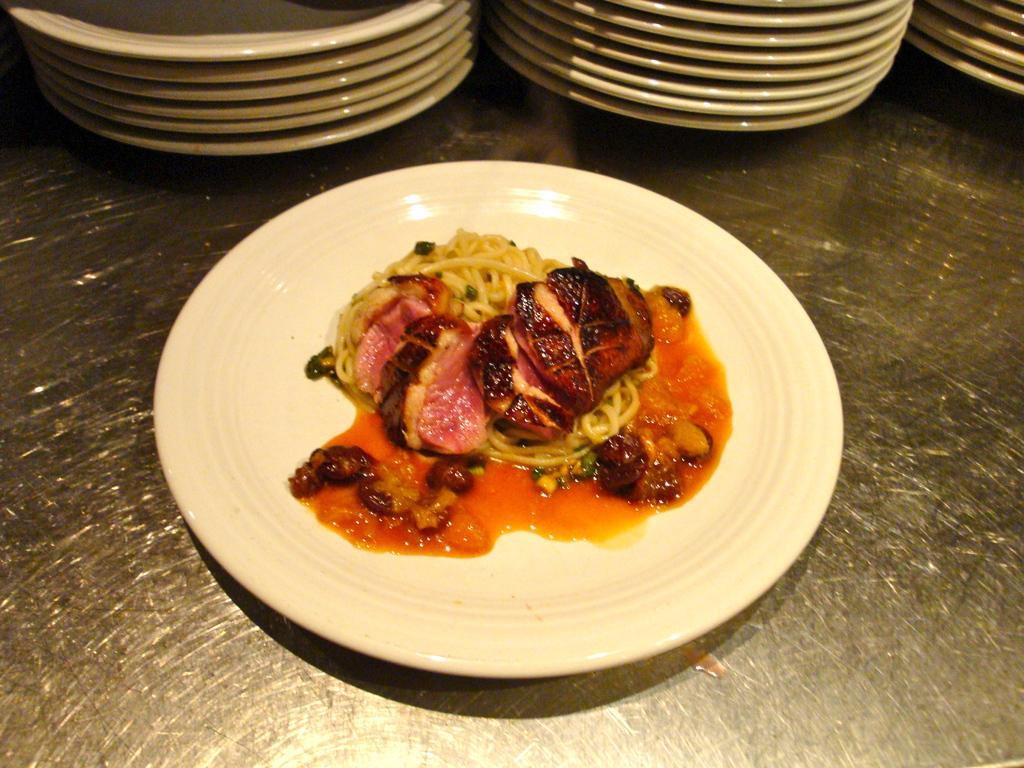Please provide a concise description of this image. In this picture I can see there is some food placed in the plate, it is placed on a surface and there are few more plates arranged in the backdrop. 